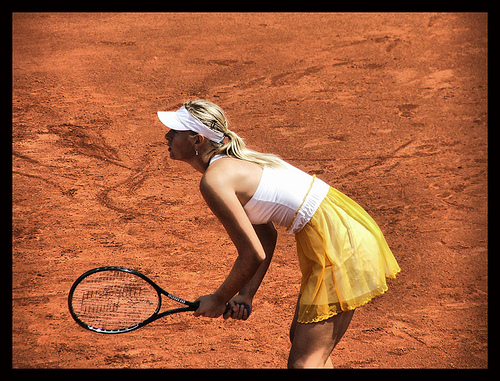<image>What tennis player is this? I don't know what tennis player is this. It could be Kournikova or Maria Sharapova. What tennis player is this? I am not sure which tennis player is this. It can be Anna Kournikova, Maria Sharapova or someone unknown. 